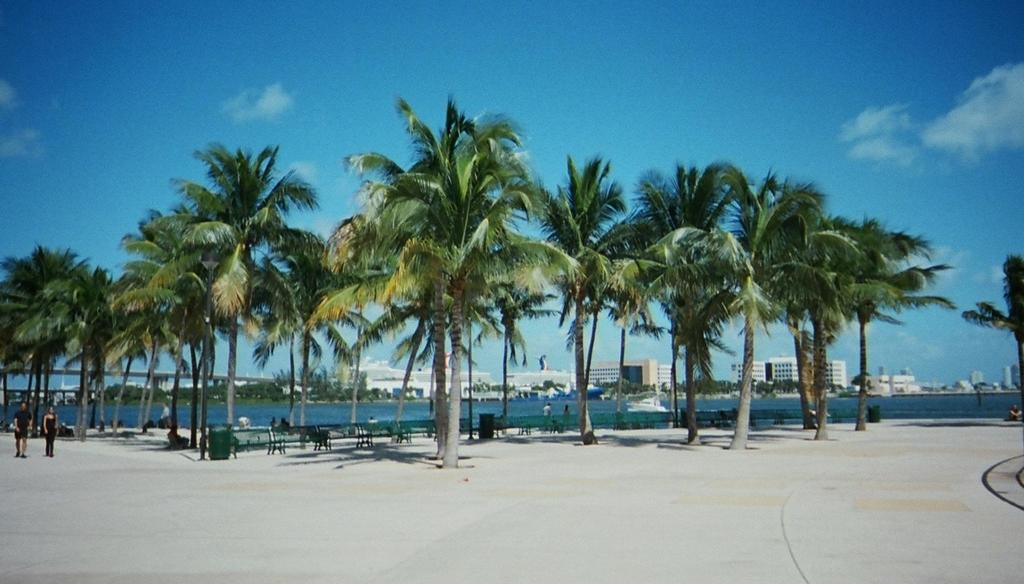What is located in the center of the image? There are trees in the center of the image. What can be found in the image for sitting? There are benches in the image. What is visible in the background of the image? There is a river, people, buildings, and the sky visible in the background of the image. How many eyes can be seen on the trees in the image? Trees do not have eyes, so there are no eyes visible on the trees in the image. What level of the building is shown in the image? The image does not specify a particular level of the building; it only shows the building in the background. 